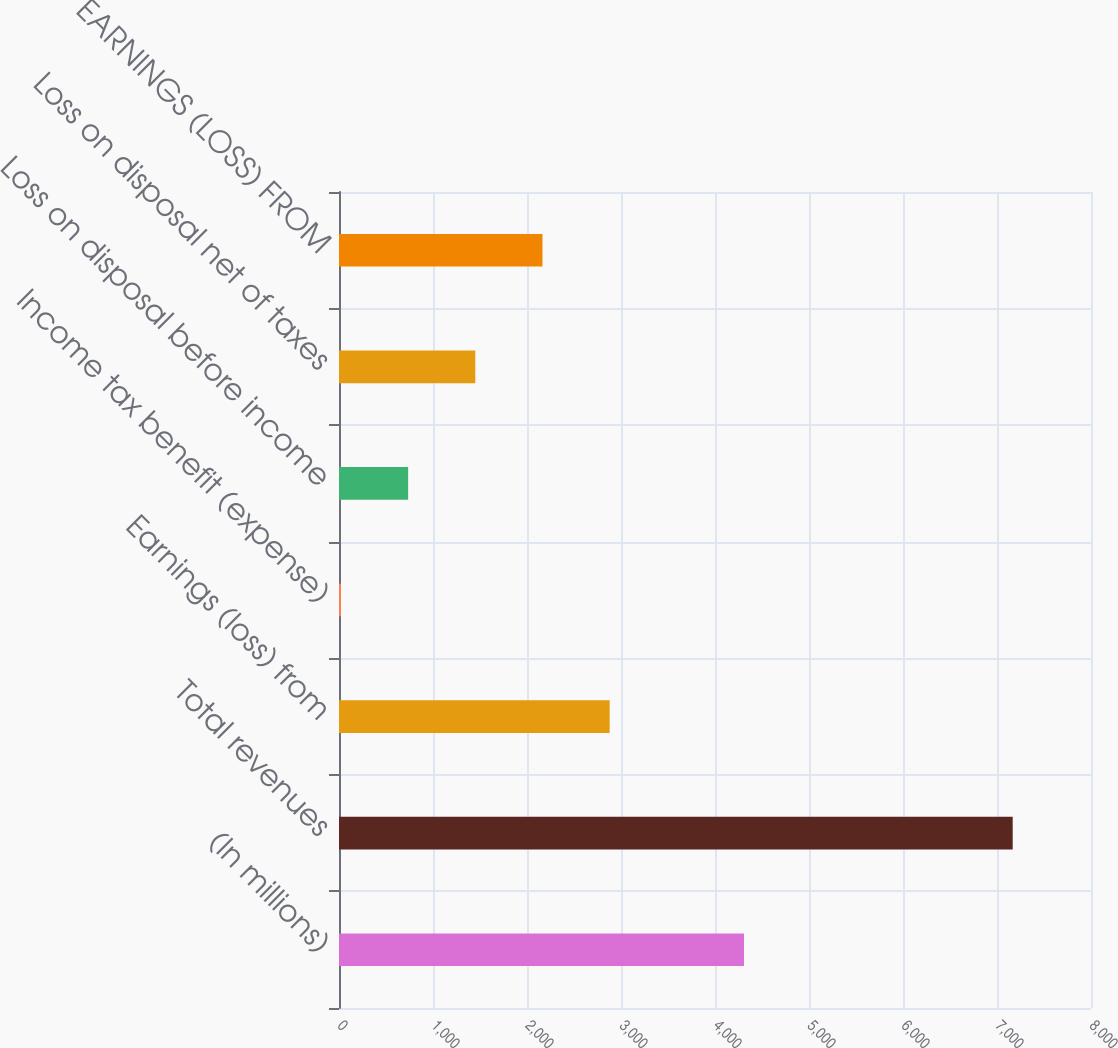<chart> <loc_0><loc_0><loc_500><loc_500><bar_chart><fcel>(In millions)<fcel>Total revenues<fcel>Earnings (loss) from<fcel>Income tax benefit (expense)<fcel>Loss on disposal before income<fcel>Loss on disposal net of taxes<fcel>EARNINGS (LOSS) FROM<nl><fcel>4308.6<fcel>7167<fcel>2879.4<fcel>21<fcel>735.6<fcel>1450.2<fcel>2164.8<nl></chart> 